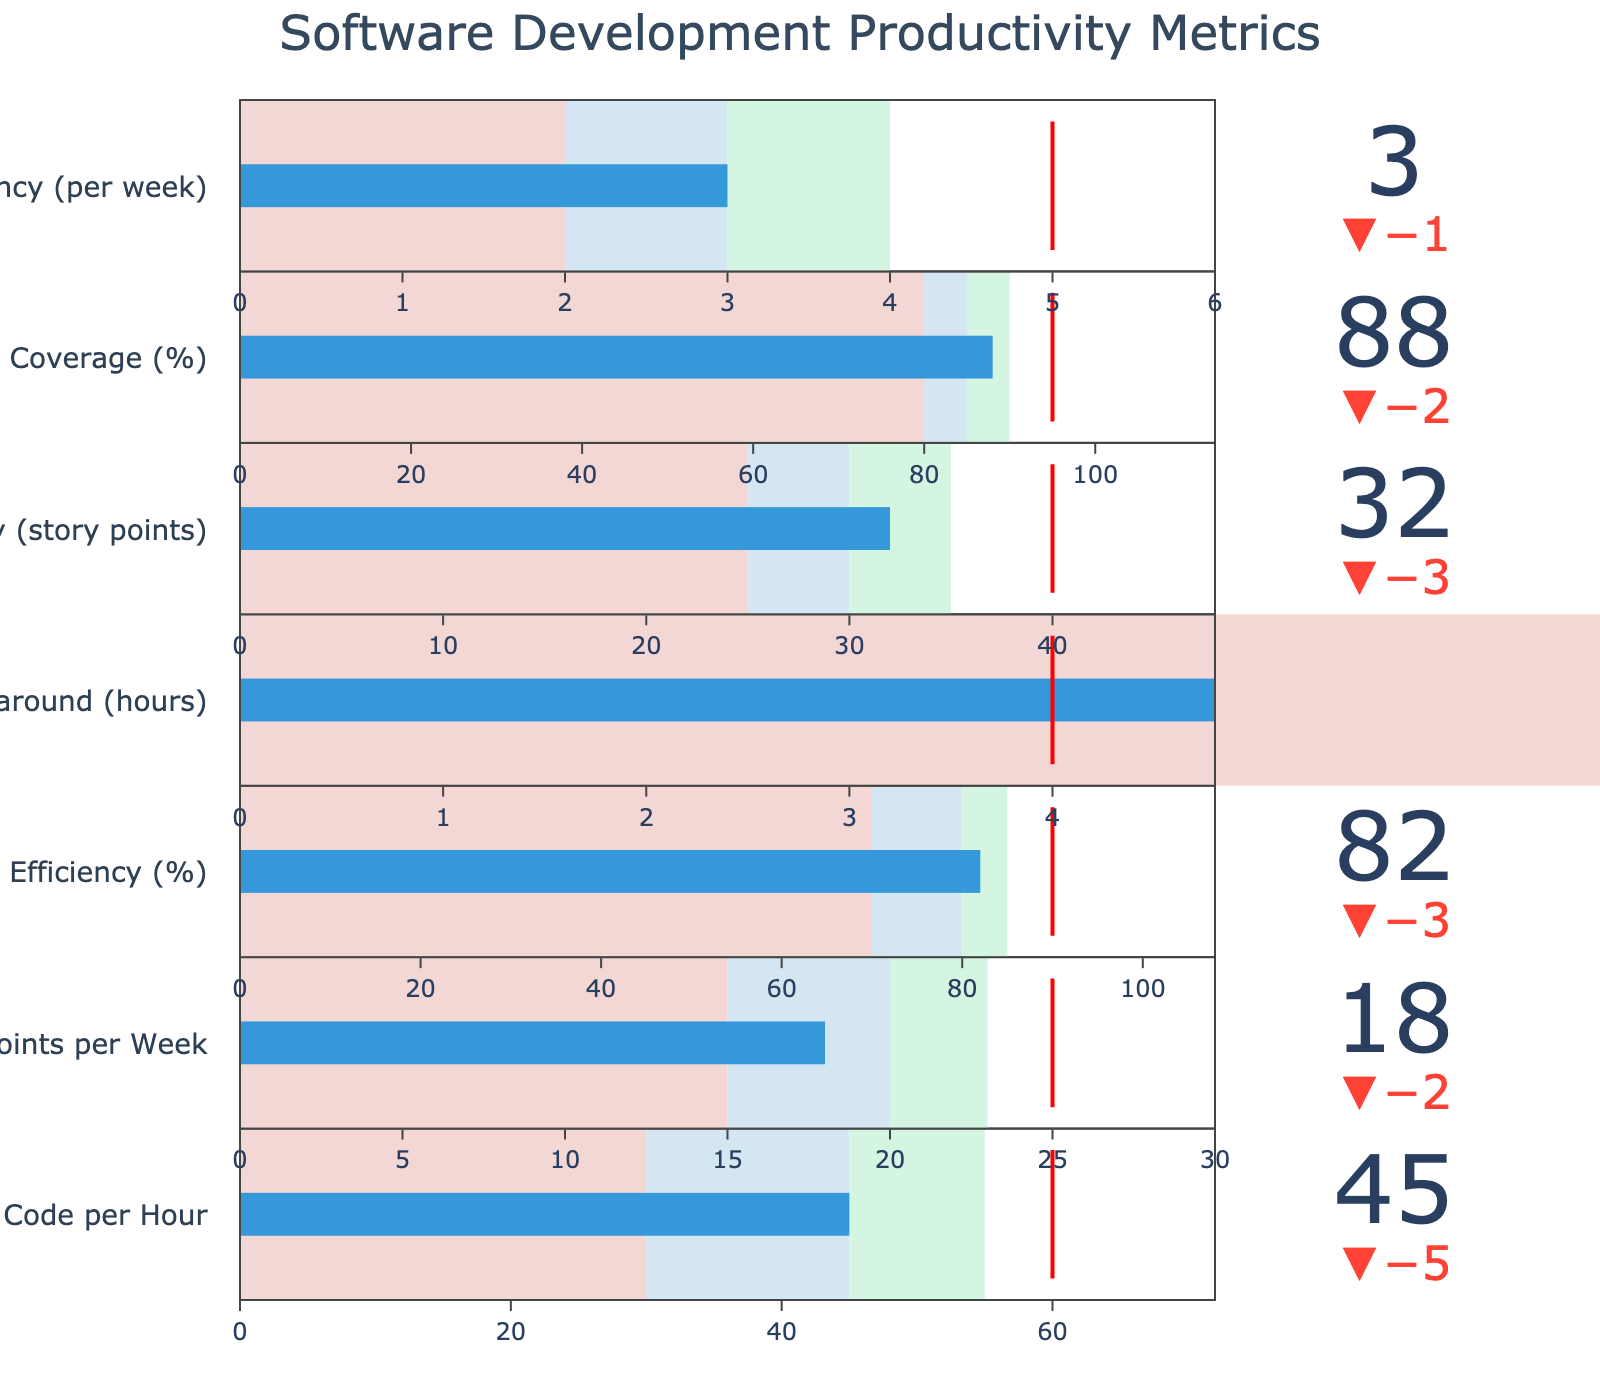what is the title of the figure? The title of the figure is written at the top center and gives an indication of what the chart is about.
Answer: "Software Development Productivity Metrics" How many different metrics are displayed in the figure? Each metric is shown as a separate bullet indicator in the figure. By counting the number of distinct indicators, we find the total number of metrics.
Answer: 7 What is the actual value for Function Points per Week, and how does it compare to the target value? The actual value for Function Points per Week can be found in the bullet chart indicated by the number beside the bar. Similarly, the target value is shown as a red line within the bullet chart. The actual value is 18 and the target is 25, so the actual is below the target.
Answer: 18 (below target) What color represents the best performance range in each metric's bullet chart? The best performance range is typically colored to stand out positively. In this case, it is represented by the green color which represents the highest range in each metric’s bullet chart.
Answer: Green How does Code Review Efficiency's actual performance compare to its comparative value? By looking at the Code Review Efficiency bullet chart, the actual performance is shown by the bar, and the comparative value is indicated by the delta symbol. The actual value (82%) is lower than the comparative value (85%).
Answer: 82% (lower than comparative) What is the difference between the industry target and the actual value for Sprint Velocity (story points)? For the Sprint Velocity metric, we find the industry target (40) and the actual value (32) as indicated on the chart. Subtract the actual value from the target: 40 - 32.
Answer: 8 story points Which metric has the closest actual value to its industry target? By comparing the difference between actual values and target values for all metrics, we see that Code Review Efficiency (actual 82%, target 90%) has a difference of 8%, which is the smallest.
Answer: Code Review Efficiency Compare the actual and comparative values for Bug Fix Turnaround. Which one is better? In the Bug Fix Turnaround metric, a lower value is better. Here, the actual value is 6 hours, while the comparative value is 5 hours. Since we look for smaller values in turnaround, the comparative performance (5 hours) is better.
Answer: Comparative (5 hours) What is the range of values that would be considered good for Test Coverage? In the bullet chart for Test Coverage, the good performance range is marked by the color right before the best (green) range, which is blue. This is from 85% to 90%.
Answer: 85% to 90% Which metric shows the worst discrepancy between actual and target values? By looking at the difference between actual values and their respective targets across all metrics, Deployment Frequency has the largest gap. The actual value is 3, while the target is 5. The difference is 2.
Answer: Deployment Frequency 